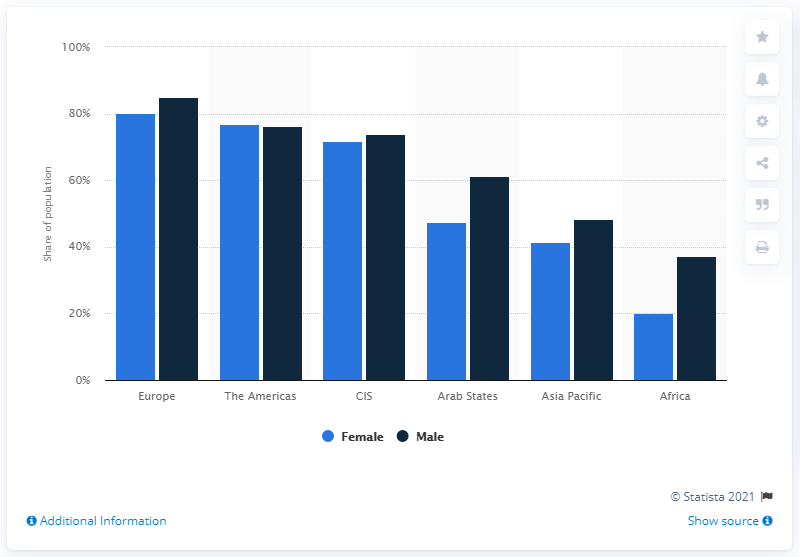Outline some significant characteristics in this image. In 2019, approximately 20.2% of Africa's female population had online access. In 2019, 37.1% of men had access to the internet. 